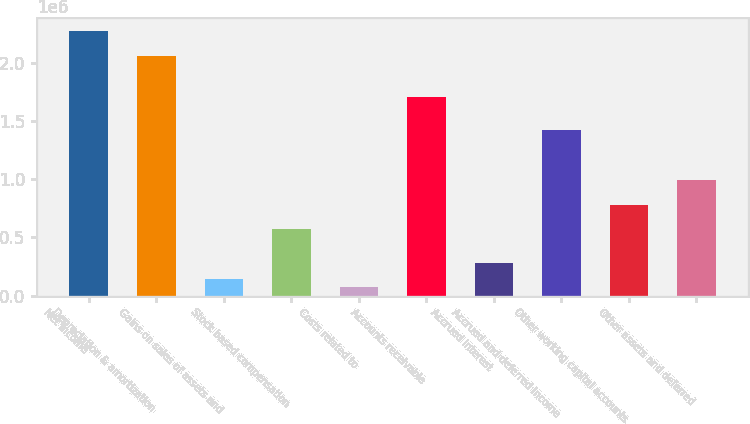Convert chart to OTSL. <chart><loc_0><loc_0><loc_500><loc_500><bar_chart><fcel>Net income<fcel>Depreciation & amortization<fcel>Gains on sales of assets and<fcel>Stock based compensation<fcel>Costs related to<fcel>Accounts receivable<fcel>Accrued interest<fcel>Accrued and deferred income<fcel>Other working capital accounts<fcel>Other assets and deferred<nl><fcel>2.27418e+06<fcel>2.06098e+06<fcel>142137<fcel>568546<fcel>71068.7<fcel>1.70564e+06<fcel>284273<fcel>1.42137e+06<fcel>781751<fcel>994956<nl></chart> 